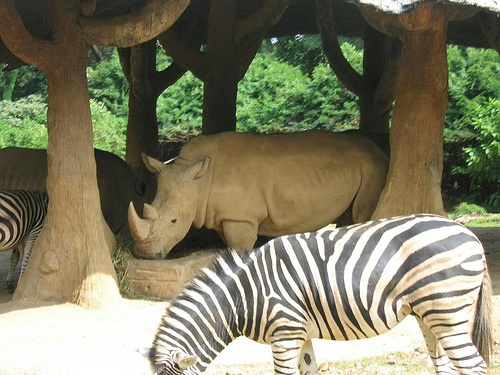Describe the objects in this image and their specific colors. I can see zebra in black, ivory, gray, darkgray, and tan tones and zebra in black, gray, and tan tones in this image. 